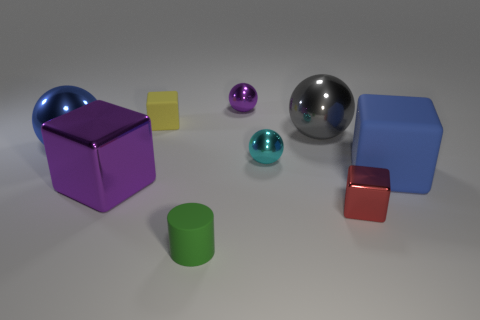Subtract 1 balls. How many balls are left? 3 Subtract all spheres. How many objects are left? 5 Subtract all small cyan metallic things. Subtract all purple metal blocks. How many objects are left? 7 Add 2 green things. How many green things are left? 3 Add 4 tiny purple balls. How many tiny purple balls exist? 5 Subtract 0 green blocks. How many objects are left? 9 